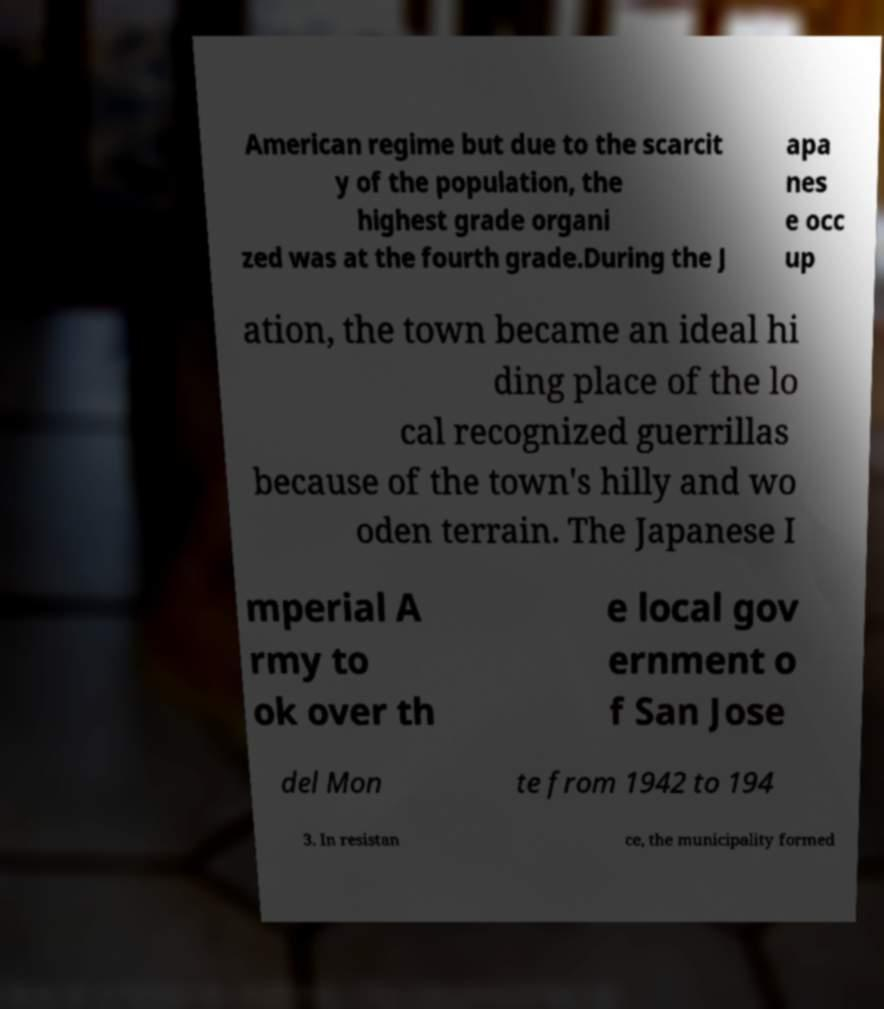Please identify and transcribe the text found in this image. American regime but due to the scarcit y of the population, the highest grade organi zed was at the fourth grade.During the J apa nes e occ up ation, the town became an ideal hi ding place of the lo cal recognized guerrillas because of the town's hilly and wo oden terrain. The Japanese I mperial A rmy to ok over th e local gov ernment o f San Jose del Mon te from 1942 to 194 3. In resistan ce, the municipality formed 